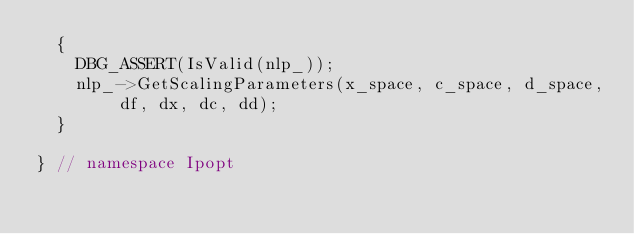<code> <loc_0><loc_0><loc_500><loc_500><_C++_>  {
    DBG_ASSERT(IsValid(nlp_));
    nlp_->GetScalingParameters(x_space, c_space, d_space, df, dx, dc, dd);
  }

} // namespace Ipopt
</code> 